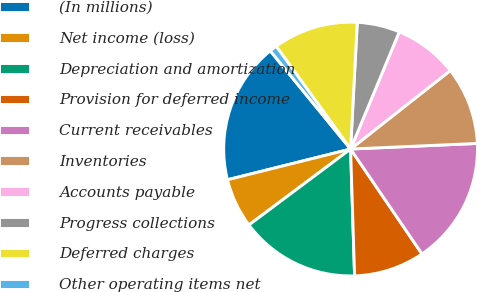<chart> <loc_0><loc_0><loc_500><loc_500><pie_chart><fcel>(In millions)<fcel>Net income (loss)<fcel>Depreciation and amortization<fcel>Provision for deferred income<fcel>Current receivables<fcel>Inventories<fcel>Accounts payable<fcel>Progress collections<fcel>Deferred charges<fcel>Other operating items net<nl><fcel>17.98%<fcel>6.32%<fcel>15.29%<fcel>9.01%<fcel>16.19%<fcel>9.91%<fcel>8.12%<fcel>5.43%<fcel>10.81%<fcel>0.94%<nl></chart> 